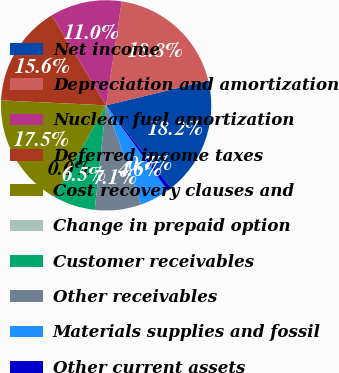Convert chart. <chart><loc_0><loc_0><loc_500><loc_500><pie_chart><fcel>Net income<fcel>Depreciation and amortization<fcel>Nuclear fuel amortization<fcel>Deferred income taxes<fcel>Cost recovery clauses and<fcel>Change in prepaid option<fcel>Customer receivables<fcel>Other receivables<fcel>Materials supplies and fossil<fcel>Other current assets<nl><fcel>18.18%<fcel>18.83%<fcel>11.04%<fcel>15.58%<fcel>17.53%<fcel>0.0%<fcel>6.49%<fcel>7.14%<fcel>4.55%<fcel>0.65%<nl></chart> 